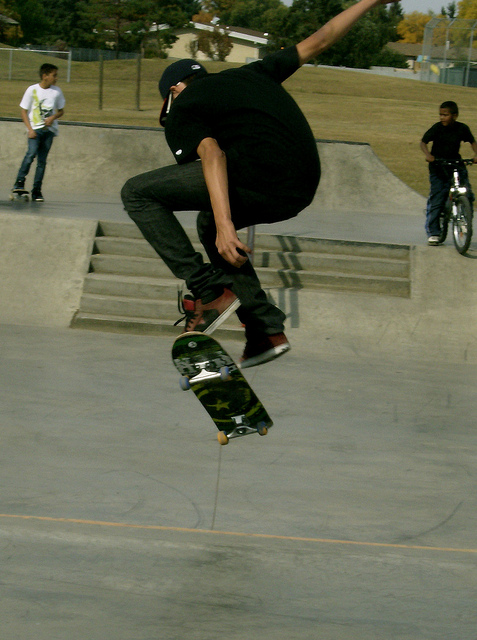<image>Is the man holding a frisbee? No, the man is not holding a frisbee. What type of art has been painted on the skate ramp? I am not sure what type of art has been painted on the skate ramp. It could be graffiti or none. Where is the man located on the tennis court? The man is not located on a tennis court. Is the man holding a frisbee? I am not sure if the man is holding a frisbee. It seems that he is not. What type of art has been painted on the skate ramp? The image does not show any type of art painted on the skate ramp. Where is the man located on the tennis court? It is unknown where the man is located on the tennis court. There is no tennis court in the image. 